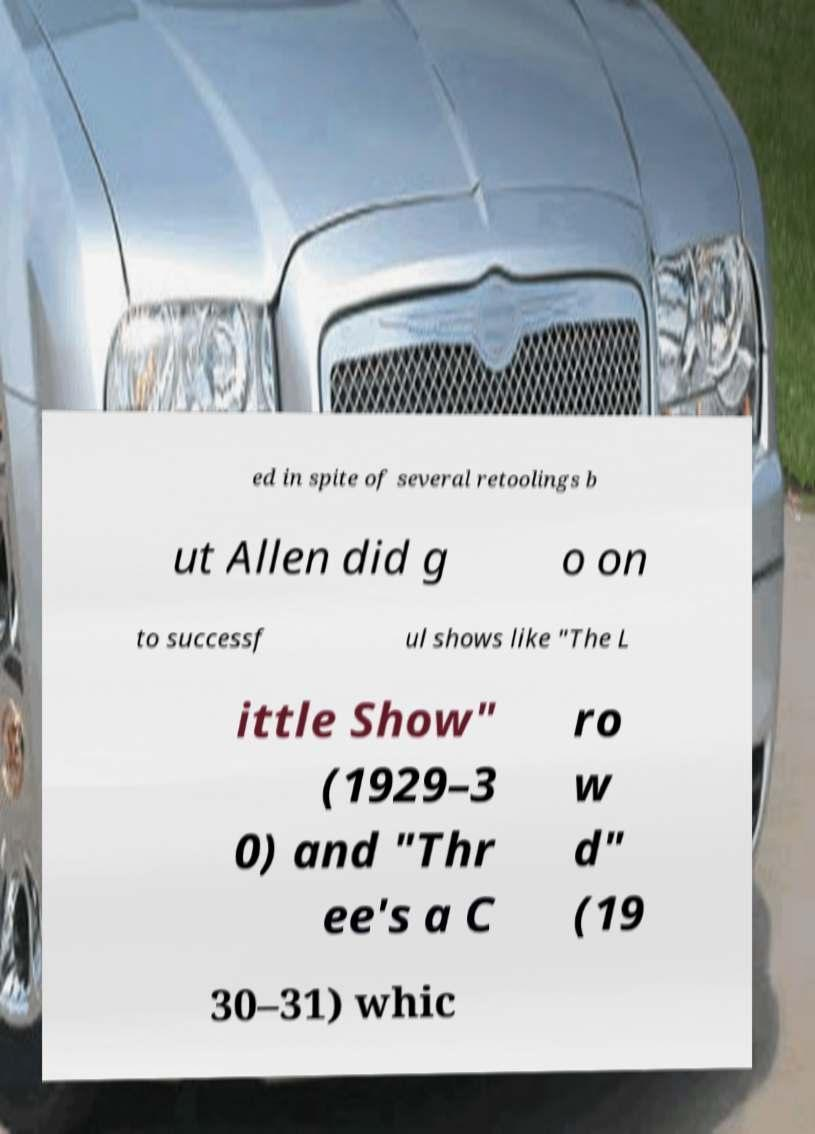Please identify and transcribe the text found in this image. ed in spite of several retoolings b ut Allen did g o on to successf ul shows like "The L ittle Show" (1929–3 0) and "Thr ee's a C ro w d" (19 30–31) whic 